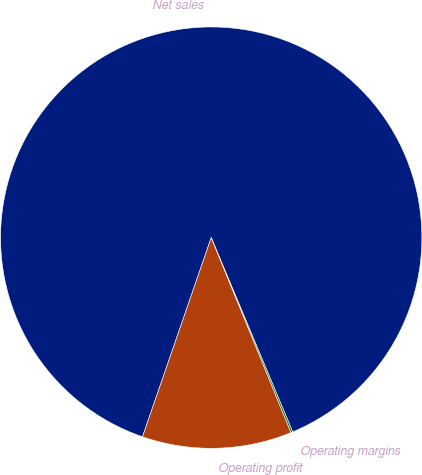<chart> <loc_0><loc_0><loc_500><loc_500><pie_chart><fcel>Net sales<fcel>Operating profit<fcel>Operating margins<nl><fcel>88.39%<fcel>11.47%<fcel>0.14%<nl></chart> 